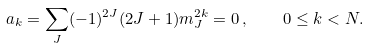Convert formula to latex. <formula><loc_0><loc_0><loc_500><loc_500>a _ { k } = \sum _ { J } ( - 1 ) ^ { 2 J } ( 2 J + 1 ) m _ { J } ^ { 2 k } = 0 \, , \quad 0 \leq k < N .</formula> 